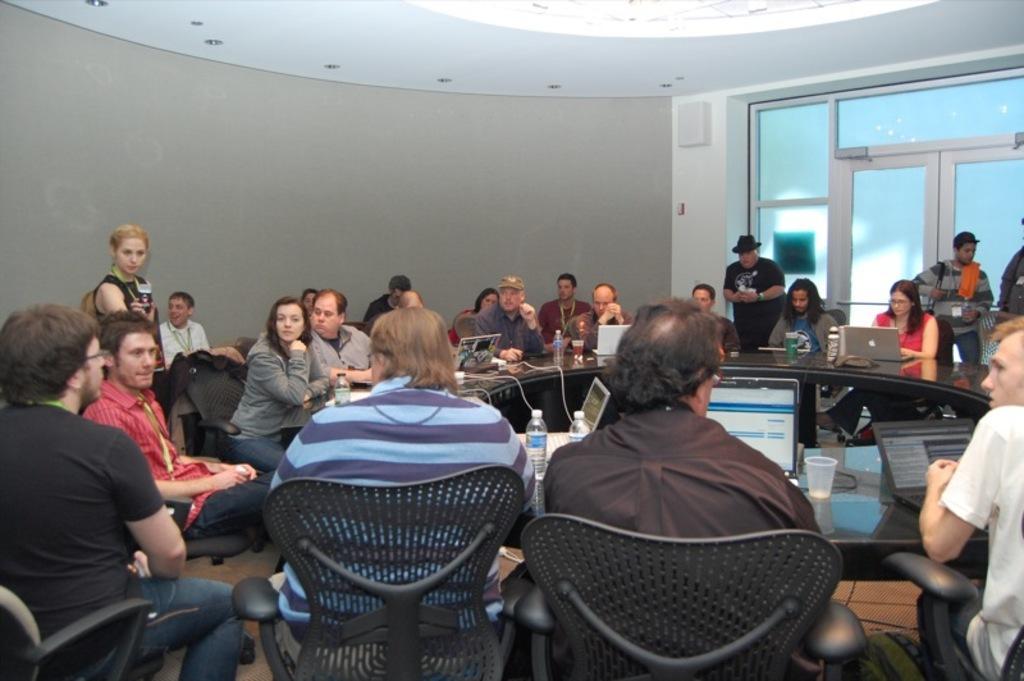Could you give a brief overview of what you see in this image? In this picture I can see few people are sitting in the chairs and I can see few laptops, water bottles on the table and I can see few are standing and I can see glass door. 